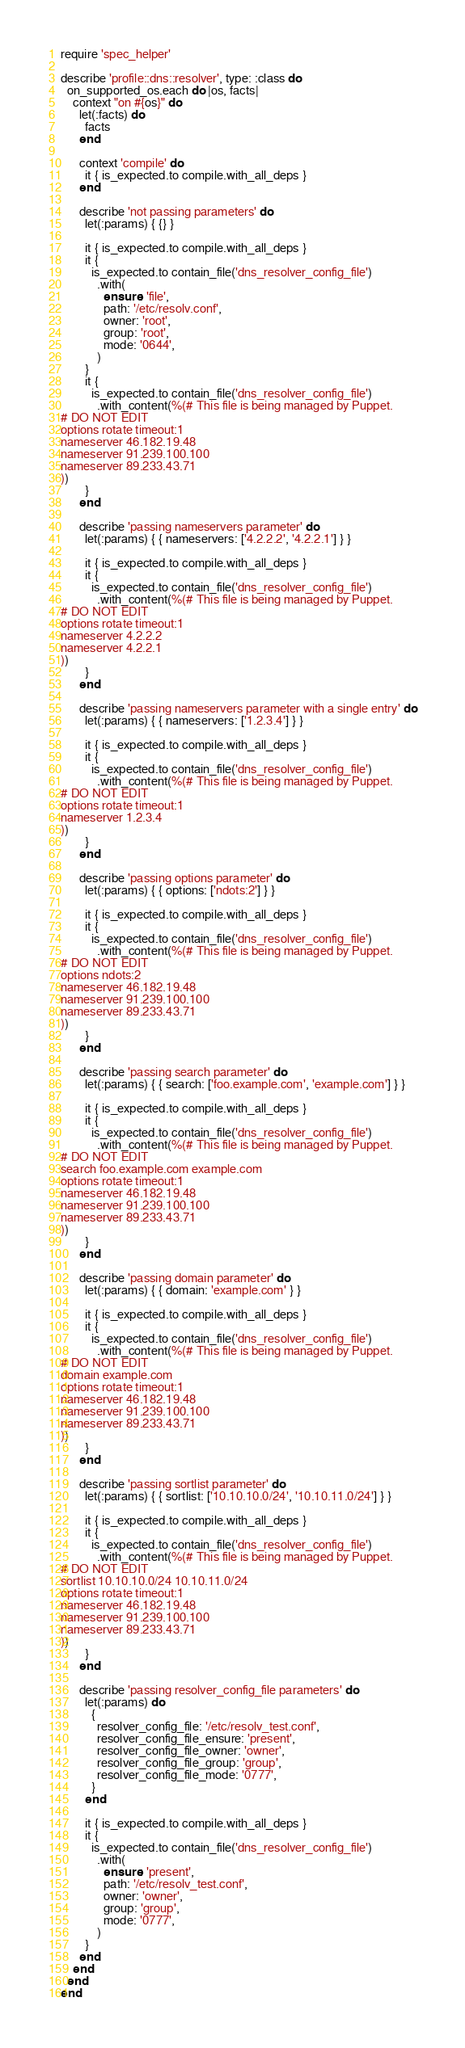<code> <loc_0><loc_0><loc_500><loc_500><_Ruby_>require 'spec_helper'

describe 'profile::dns::resolver', type: :class do
  on_supported_os.each do |os, facts|
    context "on #{os}" do
      let(:facts) do
        facts
      end

      context 'compile' do
        it { is_expected.to compile.with_all_deps }
      end

      describe 'not passing parameters' do
        let(:params) { {} }

        it { is_expected.to compile.with_all_deps }
        it {
          is_expected.to contain_file('dns_resolver_config_file')
            .with(
              ensure: 'file',
              path: '/etc/resolv.conf',
              owner: 'root',
              group: 'root',
              mode: '0644',
            )
        }
        it {
          is_expected.to contain_file('dns_resolver_config_file')
            .with_content(%(# This file is being managed by Puppet.
# DO NOT EDIT
options rotate timeout:1
nameserver 46.182.19.48
nameserver 91.239.100.100
nameserver 89.233.43.71
))
        }
      end

      describe 'passing nameservers parameter' do
        let(:params) { { nameservers: ['4.2.2.2', '4.2.2.1'] } }

        it { is_expected.to compile.with_all_deps }
        it {
          is_expected.to contain_file('dns_resolver_config_file')
            .with_content(%(# This file is being managed by Puppet.
# DO NOT EDIT
options rotate timeout:1
nameserver 4.2.2.2
nameserver 4.2.2.1
))
        }
      end

      describe 'passing nameservers parameter with a single entry' do
        let(:params) { { nameservers: ['1.2.3.4'] } }

        it { is_expected.to compile.with_all_deps }
        it {
          is_expected.to contain_file('dns_resolver_config_file')
            .with_content(%(# This file is being managed by Puppet.
# DO NOT EDIT
options rotate timeout:1
nameserver 1.2.3.4
))
        }
      end

      describe 'passing options parameter' do
        let(:params) { { options: ['ndots:2'] } }

        it { is_expected.to compile.with_all_deps }
        it {
          is_expected.to contain_file('dns_resolver_config_file')
            .with_content(%(# This file is being managed by Puppet.
# DO NOT EDIT
options ndots:2
nameserver 46.182.19.48
nameserver 91.239.100.100
nameserver 89.233.43.71
))
        }
      end

      describe 'passing search parameter' do
        let(:params) { { search: ['foo.example.com', 'example.com'] } }

        it { is_expected.to compile.with_all_deps }
        it {
          is_expected.to contain_file('dns_resolver_config_file')
            .with_content(%(# This file is being managed by Puppet.
# DO NOT EDIT
search foo.example.com example.com
options rotate timeout:1
nameserver 46.182.19.48
nameserver 91.239.100.100
nameserver 89.233.43.71
))
        }
      end

      describe 'passing domain parameter' do
        let(:params) { { domain: 'example.com' } }

        it { is_expected.to compile.with_all_deps }
        it {
          is_expected.to contain_file('dns_resolver_config_file')
            .with_content(%(# This file is being managed by Puppet.
# DO NOT EDIT
domain example.com
options rotate timeout:1
nameserver 46.182.19.48
nameserver 91.239.100.100
nameserver 89.233.43.71
))
        }
      end

      describe 'passing sortlist parameter' do
        let(:params) { { sortlist: ['10.10.10.0/24', '10.10.11.0/24'] } }

        it { is_expected.to compile.with_all_deps }
        it {
          is_expected.to contain_file('dns_resolver_config_file')
            .with_content(%(# This file is being managed by Puppet.
# DO NOT EDIT
sortlist 10.10.10.0/24 10.10.11.0/24
options rotate timeout:1
nameserver 46.182.19.48
nameserver 91.239.100.100
nameserver 89.233.43.71
))
        }
      end

      describe 'passing resolver_config_file parameters' do
        let(:params) do
          {
            resolver_config_file: '/etc/resolv_test.conf',
            resolver_config_file_ensure: 'present',
            resolver_config_file_owner: 'owner',
            resolver_config_file_group: 'group',
            resolver_config_file_mode: '0777',
          }
        end

        it { is_expected.to compile.with_all_deps }
        it {
          is_expected.to contain_file('dns_resolver_config_file')
            .with(
              ensure: 'present',
              path: '/etc/resolv_test.conf',
              owner: 'owner',
              group: 'group',
              mode: '0777',
            )
        }
      end
    end
  end
end
</code> 